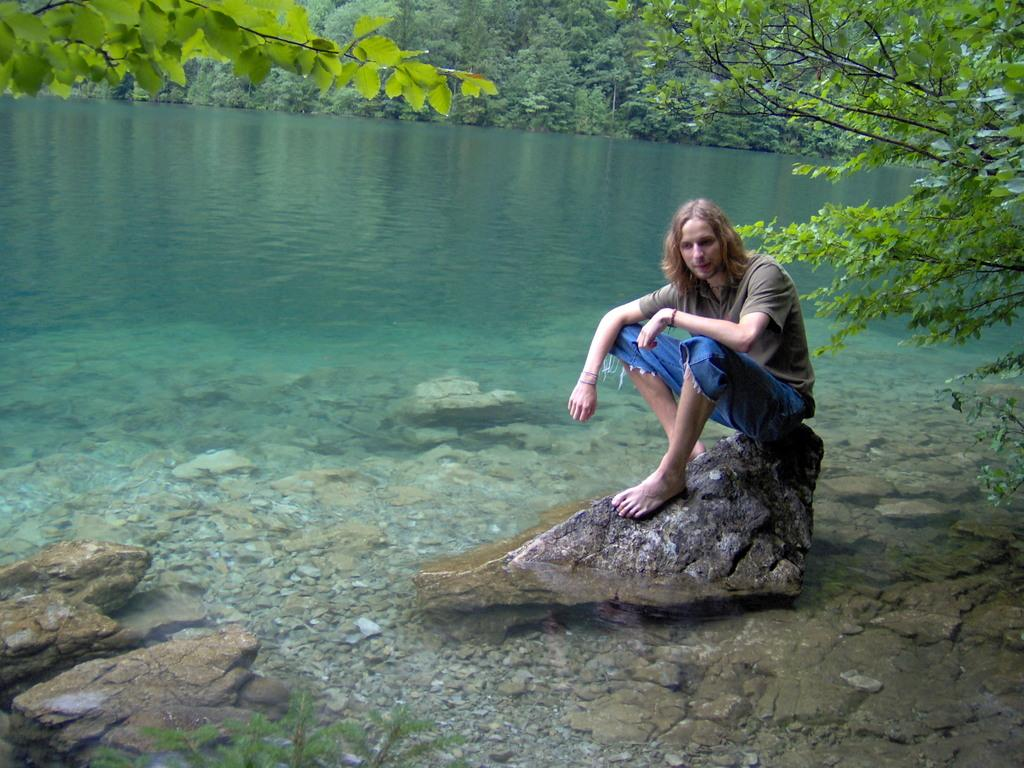What is in the water in the image? There are stones in the water in the image. What is the person in the image doing? A person is sitting on one of the stones in the image. What can be seen in the background of the image? There are trees in the background of the image. What type of battle is taking place in the image? There is no battle present in the image; it features stones in the water and a person sitting on one of them. How does the person in the image appear to be breathing? The image does not show the person's breathing, so it cannot be determined from the picture. 